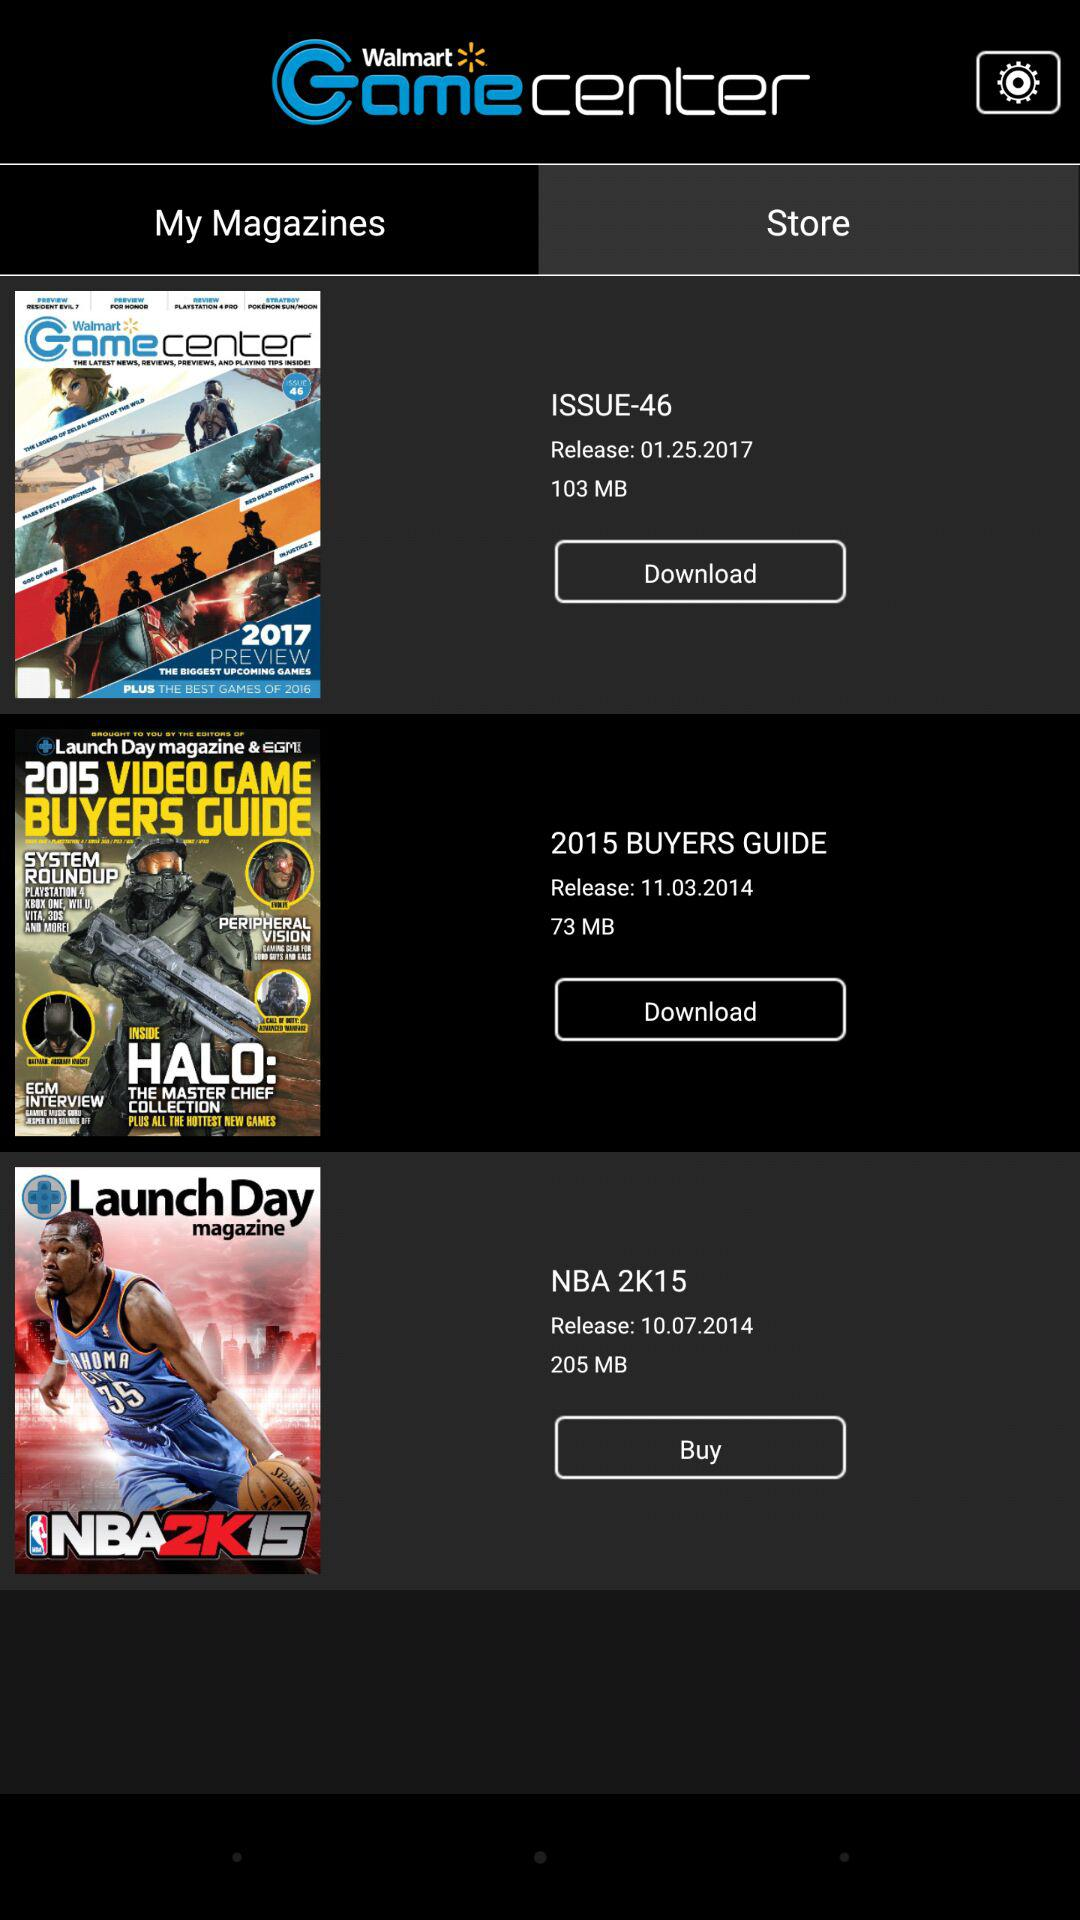How many magazines are in the My Magazines section?
Answer the question using a single word or phrase. 3 